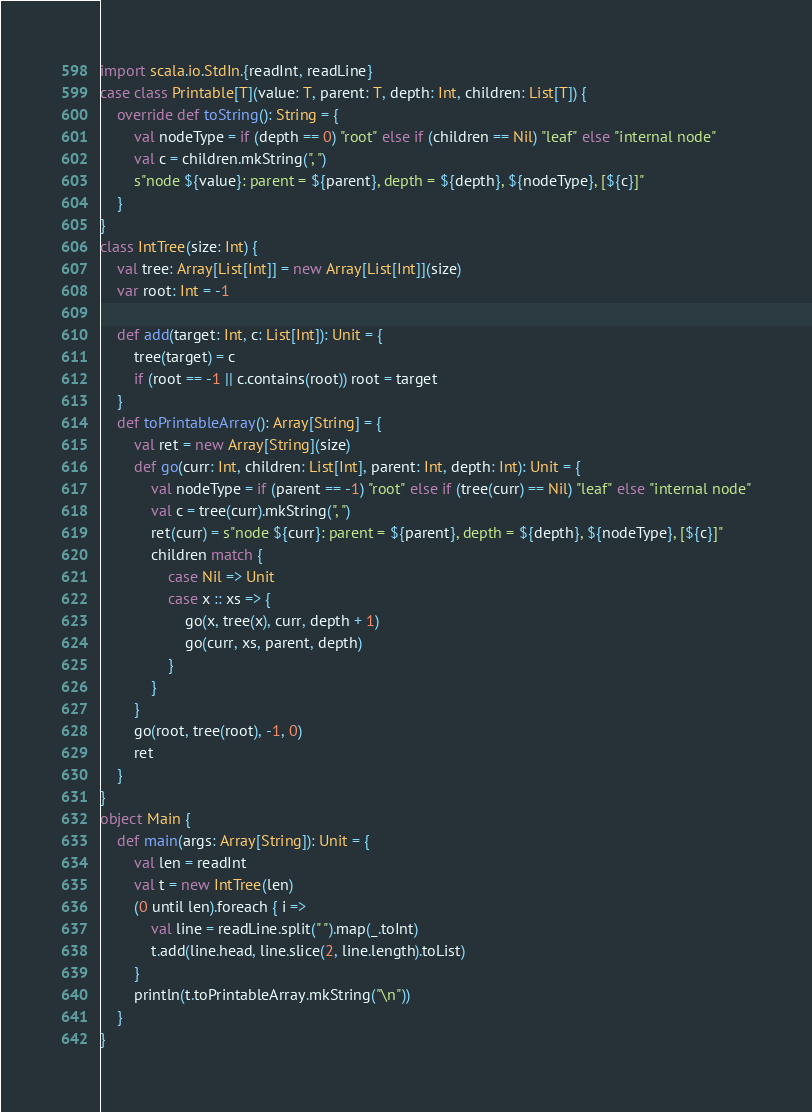Convert code to text. <code><loc_0><loc_0><loc_500><loc_500><_Scala_>import scala.io.StdIn.{readInt, readLine}
case class Printable[T](value: T, parent: T, depth: Int, children: List[T]) {
    override def toString(): String = {
        val nodeType = if (depth == 0) "root" else if (children == Nil) "leaf" else "internal node"
        val c = children.mkString(", ")
        s"node ${value}: parent = ${parent}, depth = ${depth}, ${nodeType}, [${c}]"
    }
}
class IntTree(size: Int) {
    val tree: Array[List[Int]] = new Array[List[Int]](size)
    var root: Int = -1
    
    def add(target: Int, c: List[Int]): Unit = {
        tree(target) = c
        if (root == -1 || c.contains(root)) root = target
    }
    def toPrintableArray(): Array[String] = {
        val ret = new Array[String](size)
        def go(curr: Int, children: List[Int], parent: Int, depth: Int): Unit = {
            val nodeType = if (parent == -1) "root" else if (tree(curr) == Nil) "leaf" else "internal node"
            val c = tree(curr).mkString(", ")
            ret(curr) = s"node ${curr}: parent = ${parent}, depth = ${depth}, ${nodeType}, [${c}]"
            children match {
                case Nil => Unit
                case x :: xs => {
                    go(x, tree(x), curr, depth + 1)
                    go(curr, xs, parent, depth)
                }
            }
        }
        go(root, tree(root), -1, 0)
        ret
    }
}
object Main {
    def main(args: Array[String]): Unit = {
        val len = readInt
        val t = new IntTree(len)
        (0 until len).foreach { i =>
            val line = readLine.split(" ").map(_.toInt)
            t.add(line.head, line.slice(2, line.length).toList)
        }
        println(t.toPrintableArray.mkString("\n"))
    }
}
</code> 